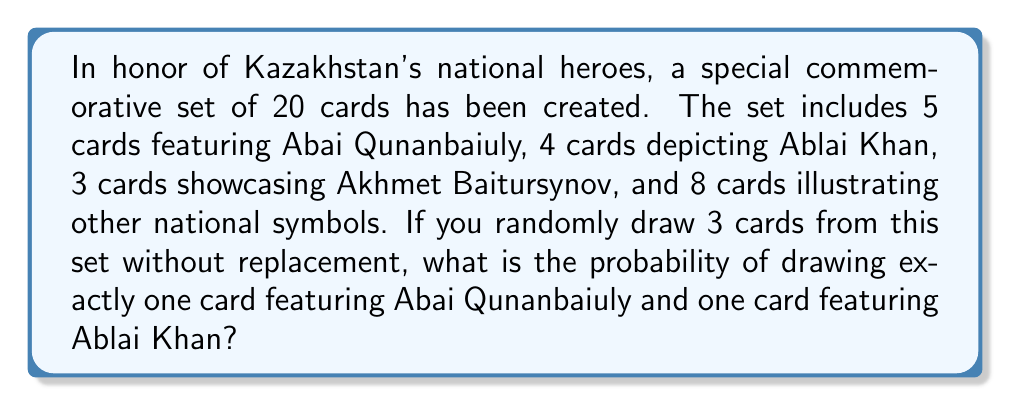What is the answer to this math problem? Let's approach this step-by-step:

1) First, we need to calculate the total number of ways to draw 3 cards from 20. This can be done using the combination formula:

   $$\binom{20}{3} = \frac{20!}{3!(20-3)!} = \frac{20!}{3!17!} = 1140$$

2) Now, we need to calculate the number of favorable outcomes. To have exactly one Abai card and one Ablai card, we need:
   - 1 Abai card (out of 5)
   - 1 Ablai card (out of 4)
   - 1 card that is neither Abai nor Ablai (out of 11)

3) We can calculate this using the multiplication principle:

   $$\binom{5}{1} \times \binom{4}{1} \times \binom{11}{1} = 5 \times 4 \times 11 = 220$$

4) The probability is then the number of favorable outcomes divided by the total number of possible outcomes:

   $$P(\text{1 Abai, 1 Ablai, 1 Other}) = \frac{220}{1140} = \frac{11}{57} \approx 0.1930$$
Answer: The probability of drawing exactly one card featuring Abai Qunanbaiuly and one card featuring Ablai Khan when drawing 3 cards from the set is $\frac{11}{57}$ or approximately 0.1930 (19.30%). 